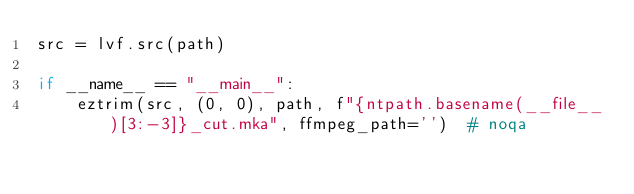<code> <loc_0><loc_0><loc_500><loc_500><_Python_>src = lvf.src(path)

if __name__ == "__main__":
    eztrim(src, (0, 0), path, f"{ntpath.basename(__file__)[3:-3]}_cut.mka", ffmpeg_path='')  # noqa
</code> 